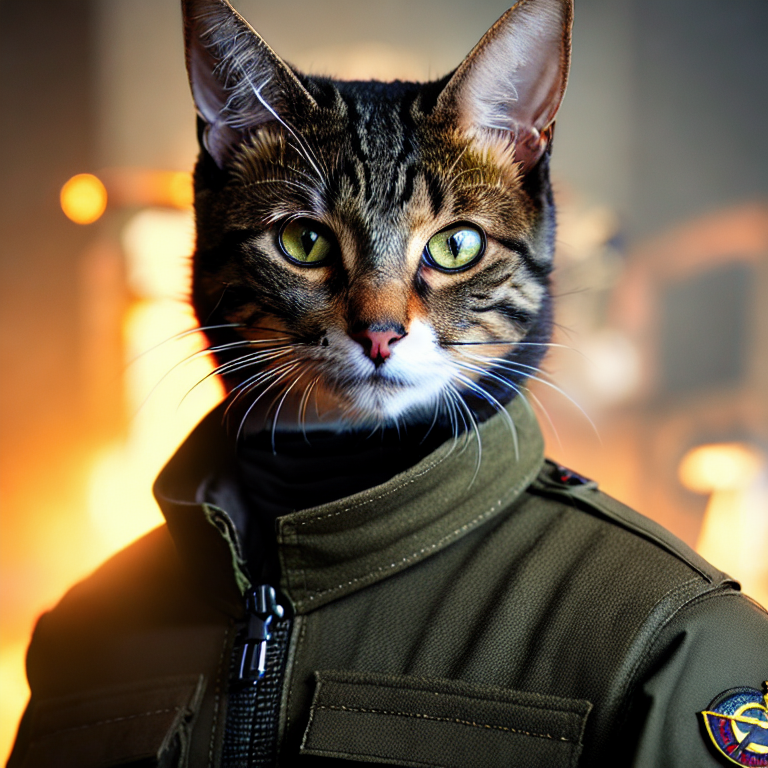What might be the story or concept behind this cat dressed in military attire? This image might represent a fictional tale, where cats, characterized by their agility and sharp senses, play roles as heroes in a military setting. It could be part of a larger narrative that explores themes of courage and teamwork in an imaginative, animal-centric universe. Such depictions could also be a satirical commentary on human conflict, utilizing the innocence of animals to highlight the absurdities of war. 